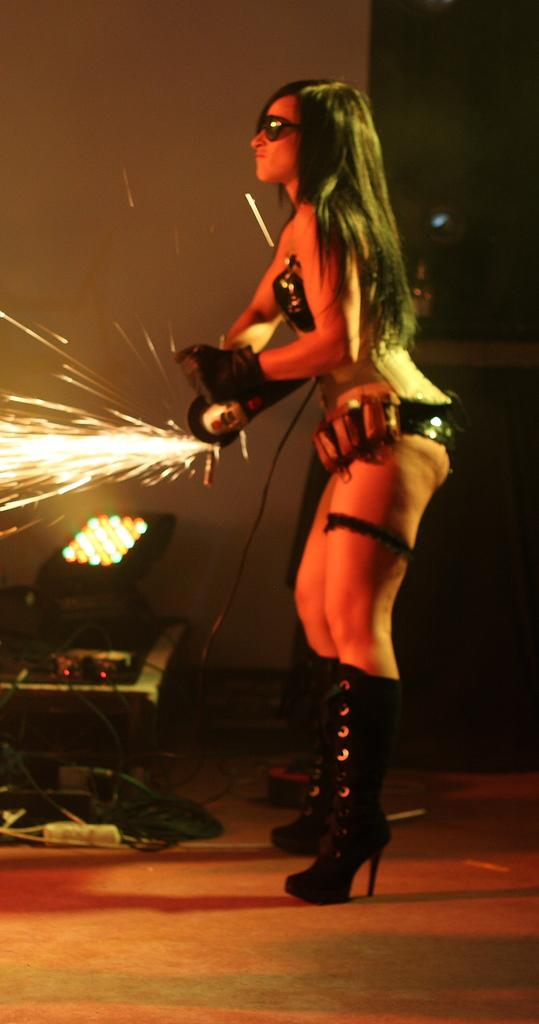Who is the main subject in the image? There is a woman in the image. What is the woman doing in the image? The woman is standing on the floor. What is the woman holding in her hand? The woman is holding an object in her hand. What can be seen in the background of the image? There is a wall and a light in the background of the image. What type of weather can be seen in the image? There is no weather mentioned or depicted in the image. Who is the inventor of the object the woman is holding in the image? The image does not provide information about the inventor of the object the woman is holding. 